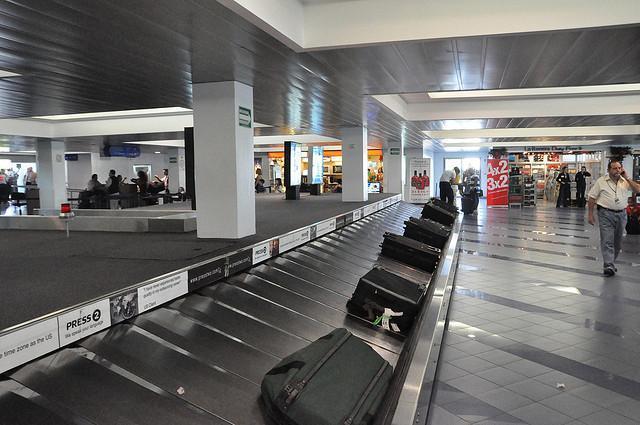How many suitcases are on the belt?
Give a very brief answer. 5. How many suitcases are there?
Give a very brief answer. 2. 